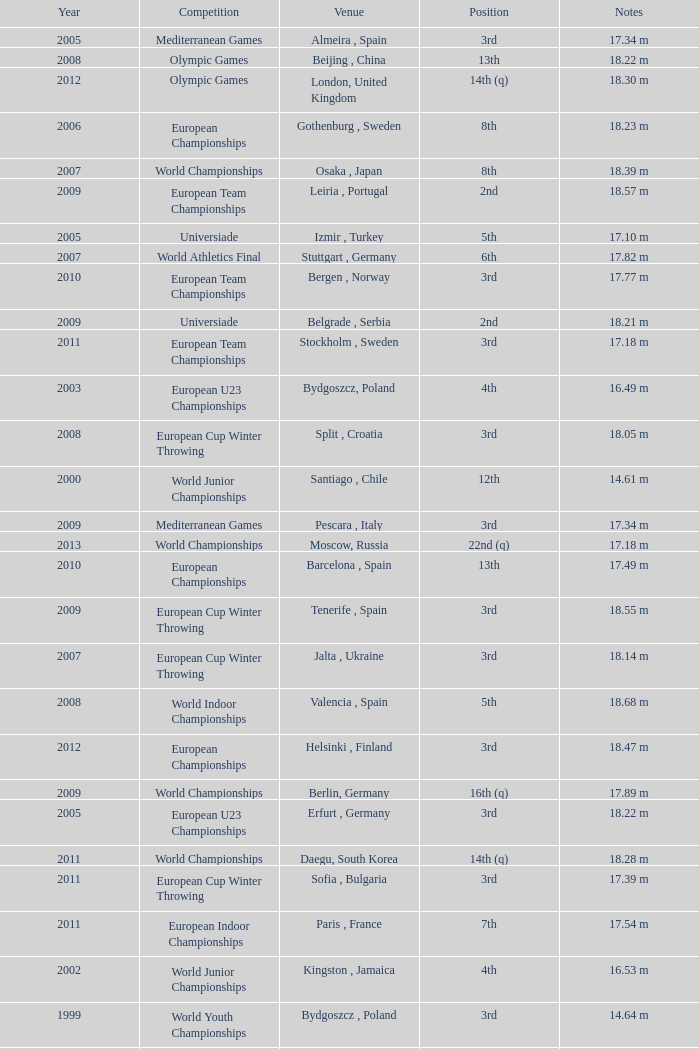What position is 1999? 3rd. 